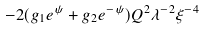<formula> <loc_0><loc_0><loc_500><loc_500>- 2 ( g _ { 1 } e ^ { \psi } + g _ { 2 } e ^ { - \psi } ) Q ^ { 2 } \lambda ^ { - 2 } \xi ^ { - 4 }</formula> 